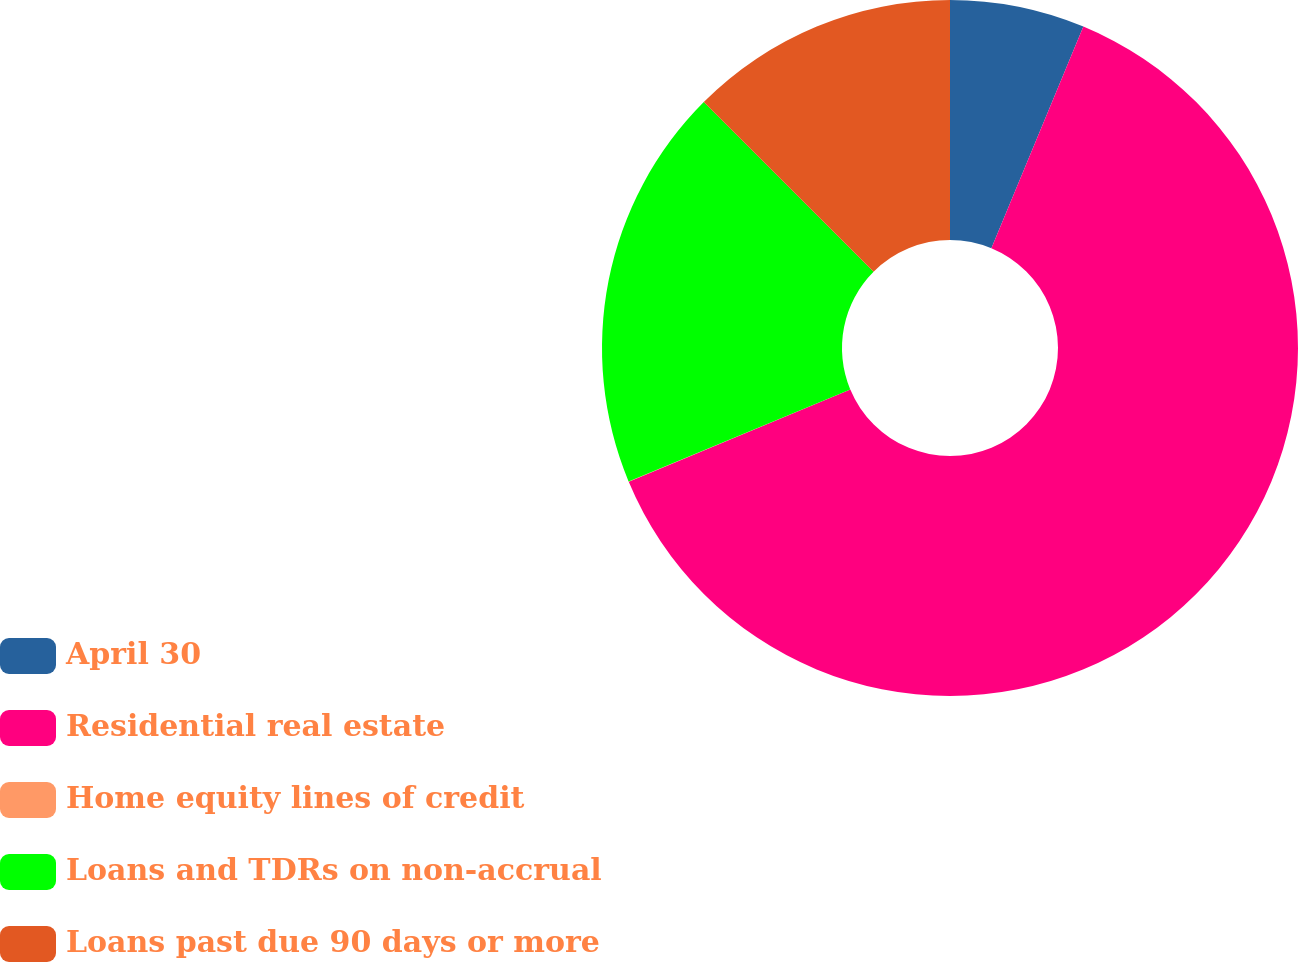Convert chart. <chart><loc_0><loc_0><loc_500><loc_500><pie_chart><fcel>April 30<fcel>Residential real estate<fcel>Home equity lines of credit<fcel>Loans and TDRs on non-accrual<fcel>Loans past due 90 days or more<nl><fcel>6.26%<fcel>62.46%<fcel>0.02%<fcel>18.75%<fcel>12.51%<nl></chart> 